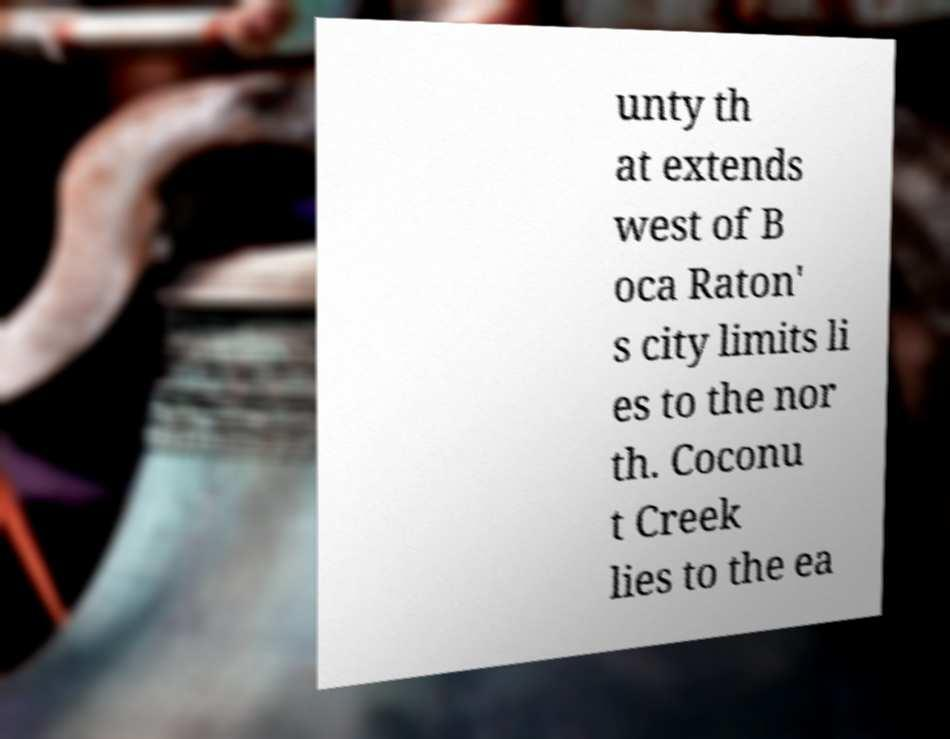I need the written content from this picture converted into text. Can you do that? unty th at extends west of B oca Raton' s city limits li es to the nor th. Coconu t Creek lies to the ea 